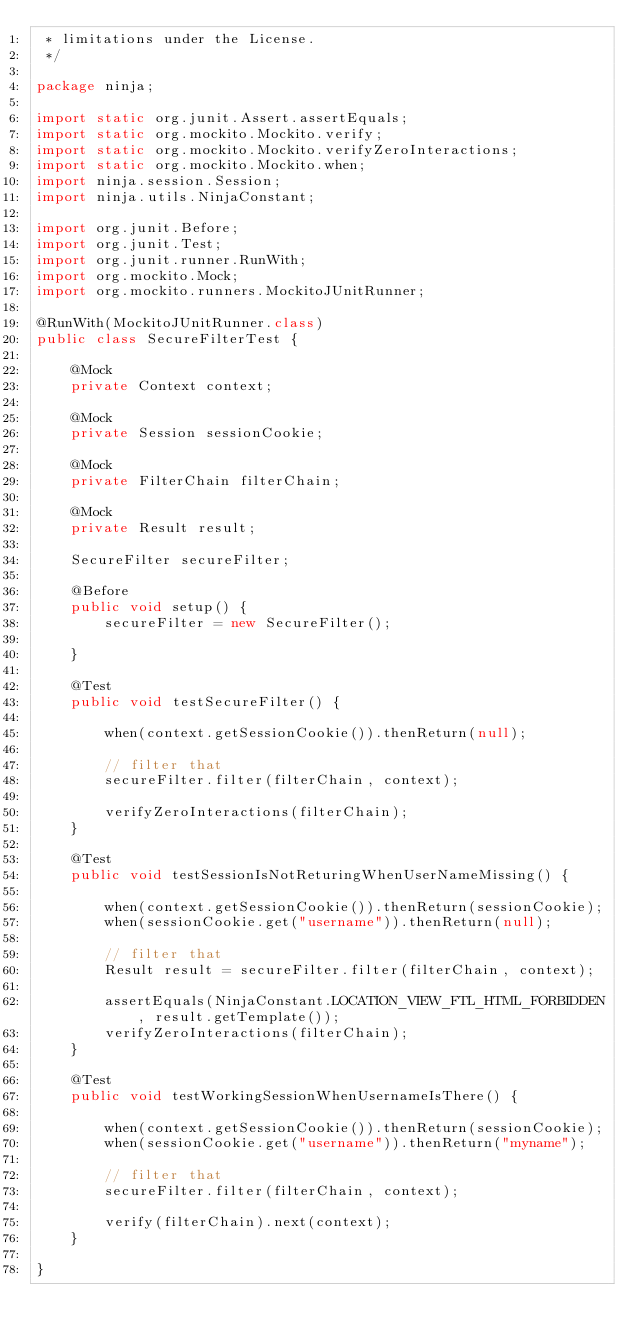Convert code to text. <code><loc_0><loc_0><loc_500><loc_500><_Java_> * limitations under the License.
 */

package ninja;

import static org.junit.Assert.assertEquals;
import static org.mockito.Mockito.verify;
import static org.mockito.Mockito.verifyZeroInteractions;
import static org.mockito.Mockito.when;
import ninja.session.Session;
import ninja.utils.NinjaConstant;

import org.junit.Before;
import org.junit.Test;
import org.junit.runner.RunWith;
import org.mockito.Mock;
import org.mockito.runners.MockitoJUnitRunner;

@RunWith(MockitoJUnitRunner.class)
public class SecureFilterTest {

    @Mock
    private Context context;
    
    @Mock
    private Session sessionCookie;

    @Mock 
    private FilterChain filterChain;
    
    @Mock 
    private Result result;

    SecureFilter secureFilter;

    @Before
    public void setup() {
        secureFilter = new SecureFilter();

    }

    @Test
    public void testSecureFilter() {

        when(context.getSessionCookie()).thenReturn(null);

        // filter that
        secureFilter.filter(filterChain, context);

        verifyZeroInteractions(filterChain);
    }
    
    @Test
    public void testSessionIsNotReturingWhenUserNameMissing() {

        when(context.getSessionCookie()).thenReturn(sessionCookie);
        when(sessionCookie.get("username")).thenReturn(null);
        
        // filter that
        Result result = secureFilter.filter(filterChain, context);
        
        assertEquals(NinjaConstant.LOCATION_VIEW_FTL_HTML_FORBIDDEN, result.getTemplate());
        verifyZeroInteractions(filterChain);
    }

    @Test
    public void testWorkingSessionWhenUsernameIsThere() {

        when(context.getSessionCookie()).thenReturn(sessionCookie);
        when(sessionCookie.get("username")).thenReturn("myname");
        
        // filter that
        secureFilter.filter(filterChain, context);

        verify(filterChain).next(context);
    }

}
</code> 